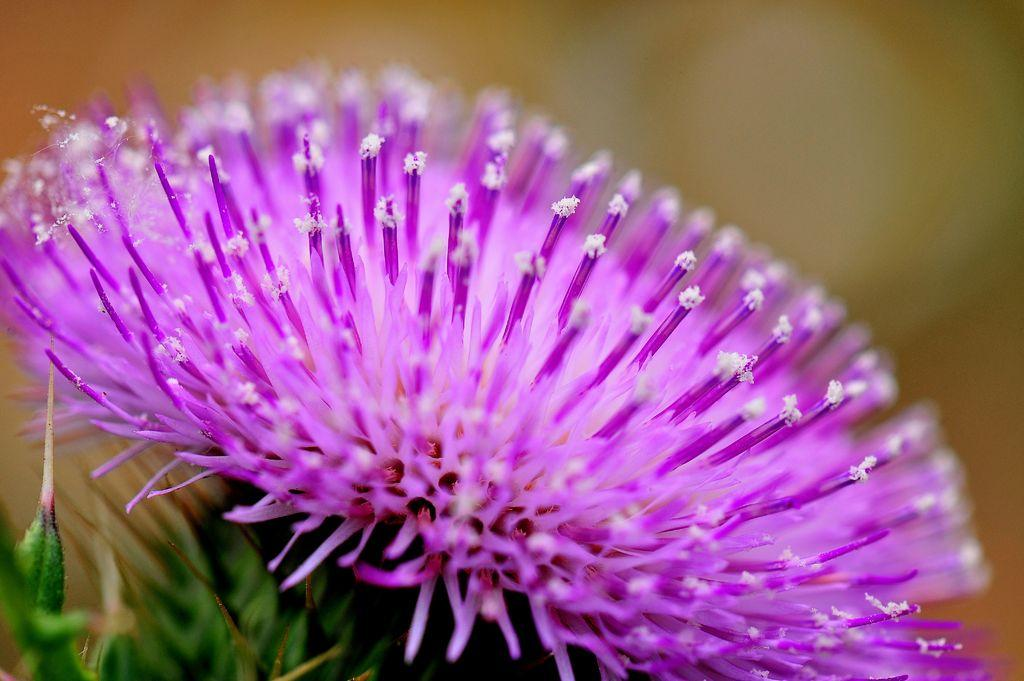What is the main subject of the image? There is a flower in the image. What type of cakes are being served at the society event depicted in the image? There is no society event or cakes present in the image; it only features a flower. 